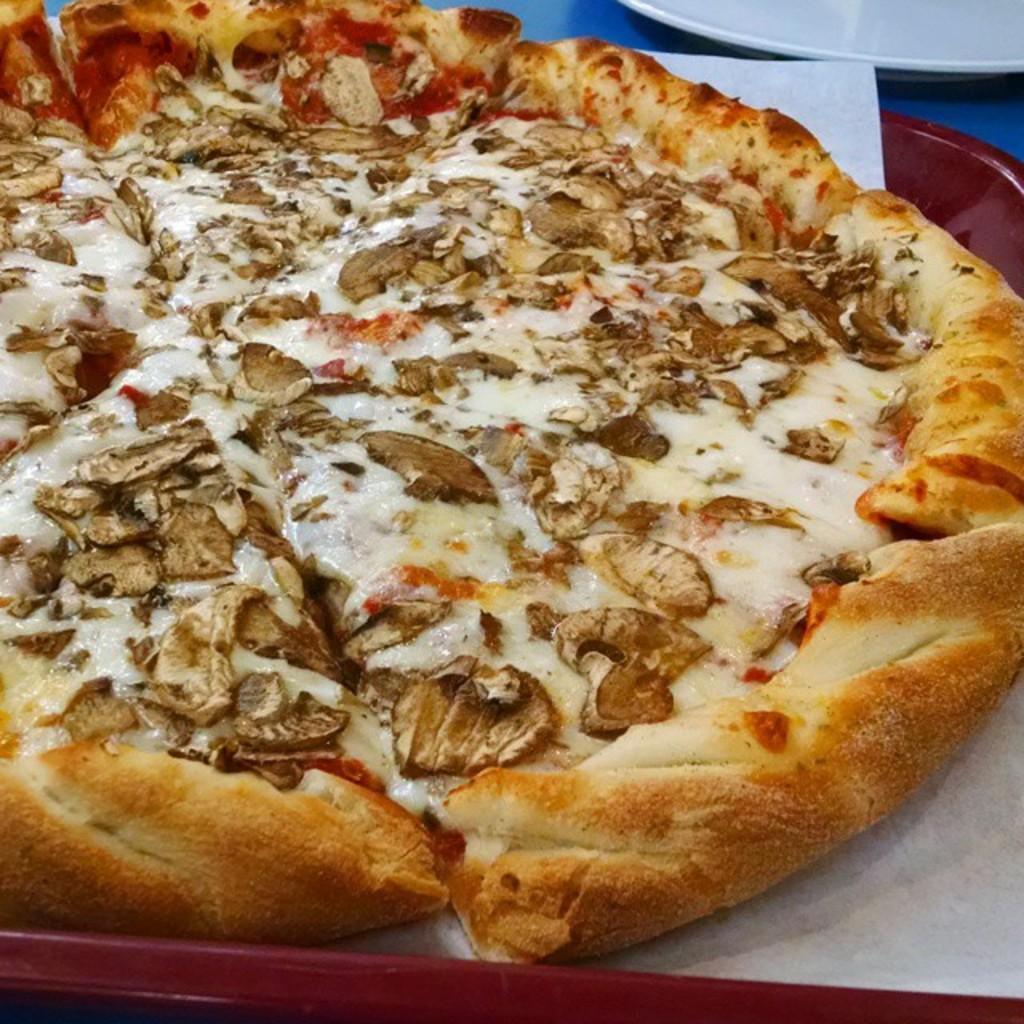How would you summarize this image in a sentence or two? In this image we can see a pizza with a paper in a plate which is placed on the surface. On the top of the image we can see a plate. 